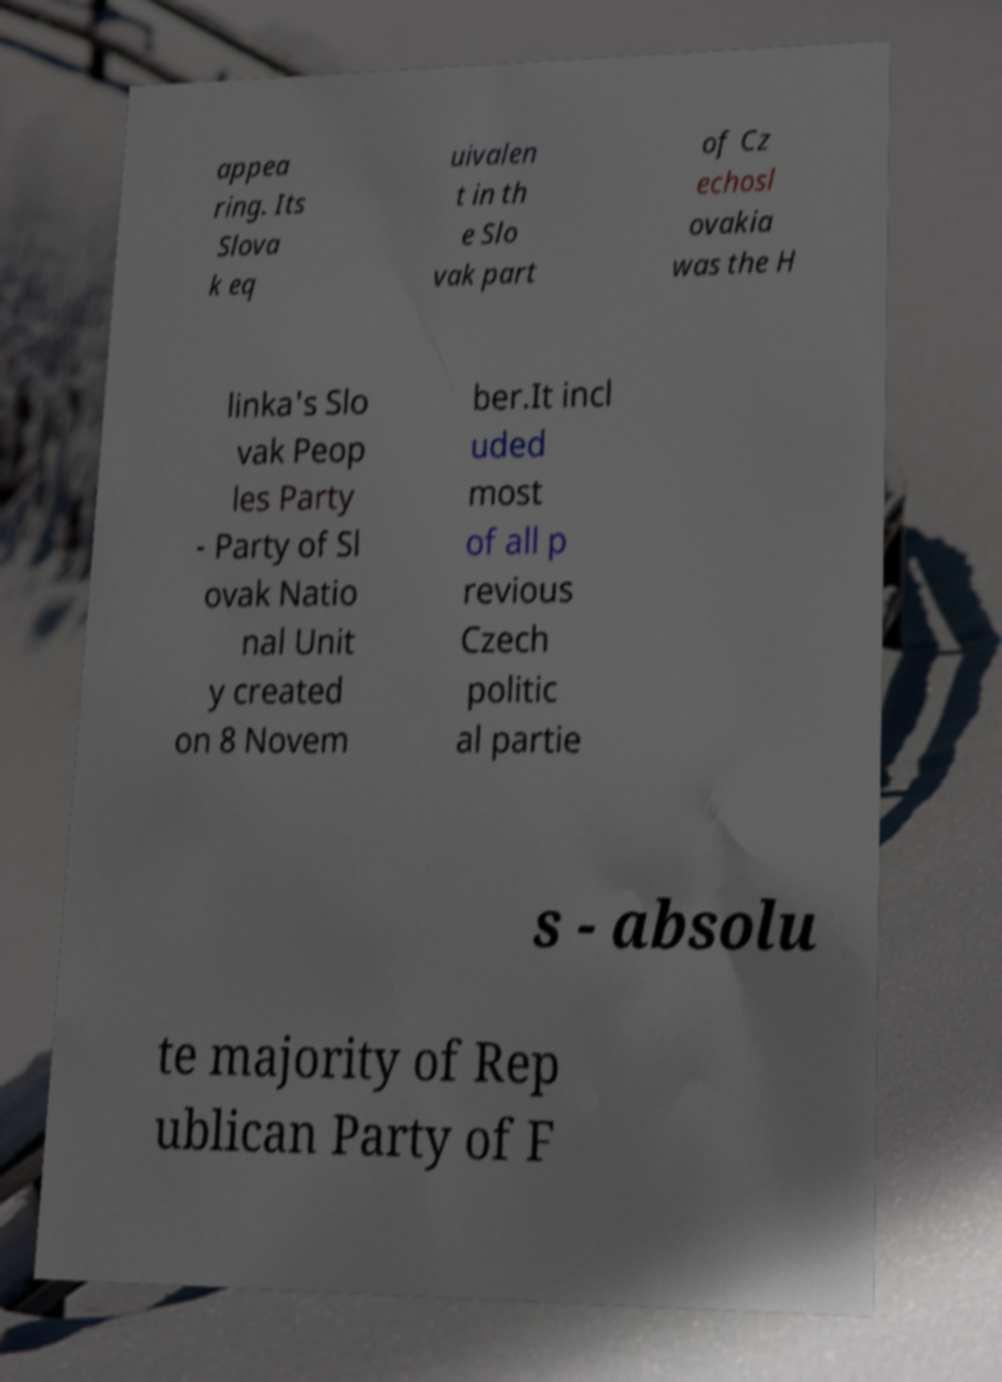Can you read and provide the text displayed in the image?This photo seems to have some interesting text. Can you extract and type it out for me? appea ring. Its Slova k eq uivalen t in th e Slo vak part of Cz echosl ovakia was the H linka's Slo vak Peop les Party - Party of Sl ovak Natio nal Unit y created on 8 Novem ber.It incl uded most of all p revious Czech politic al partie s - absolu te majority of Rep ublican Party of F 